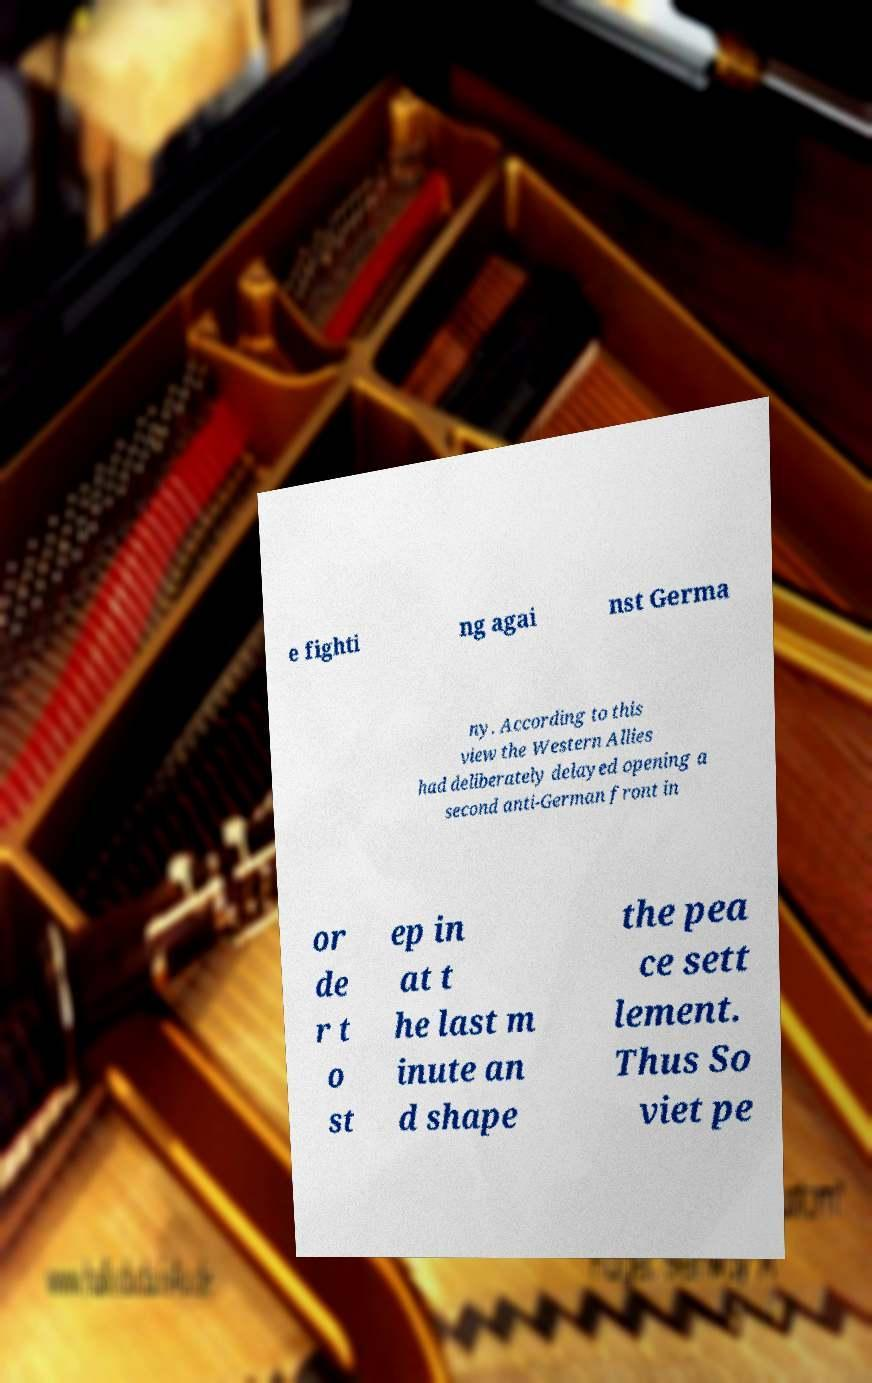Can you read and provide the text displayed in the image?This photo seems to have some interesting text. Can you extract and type it out for me? e fighti ng agai nst Germa ny. According to this view the Western Allies had deliberately delayed opening a second anti-German front in or de r t o st ep in at t he last m inute an d shape the pea ce sett lement. Thus So viet pe 